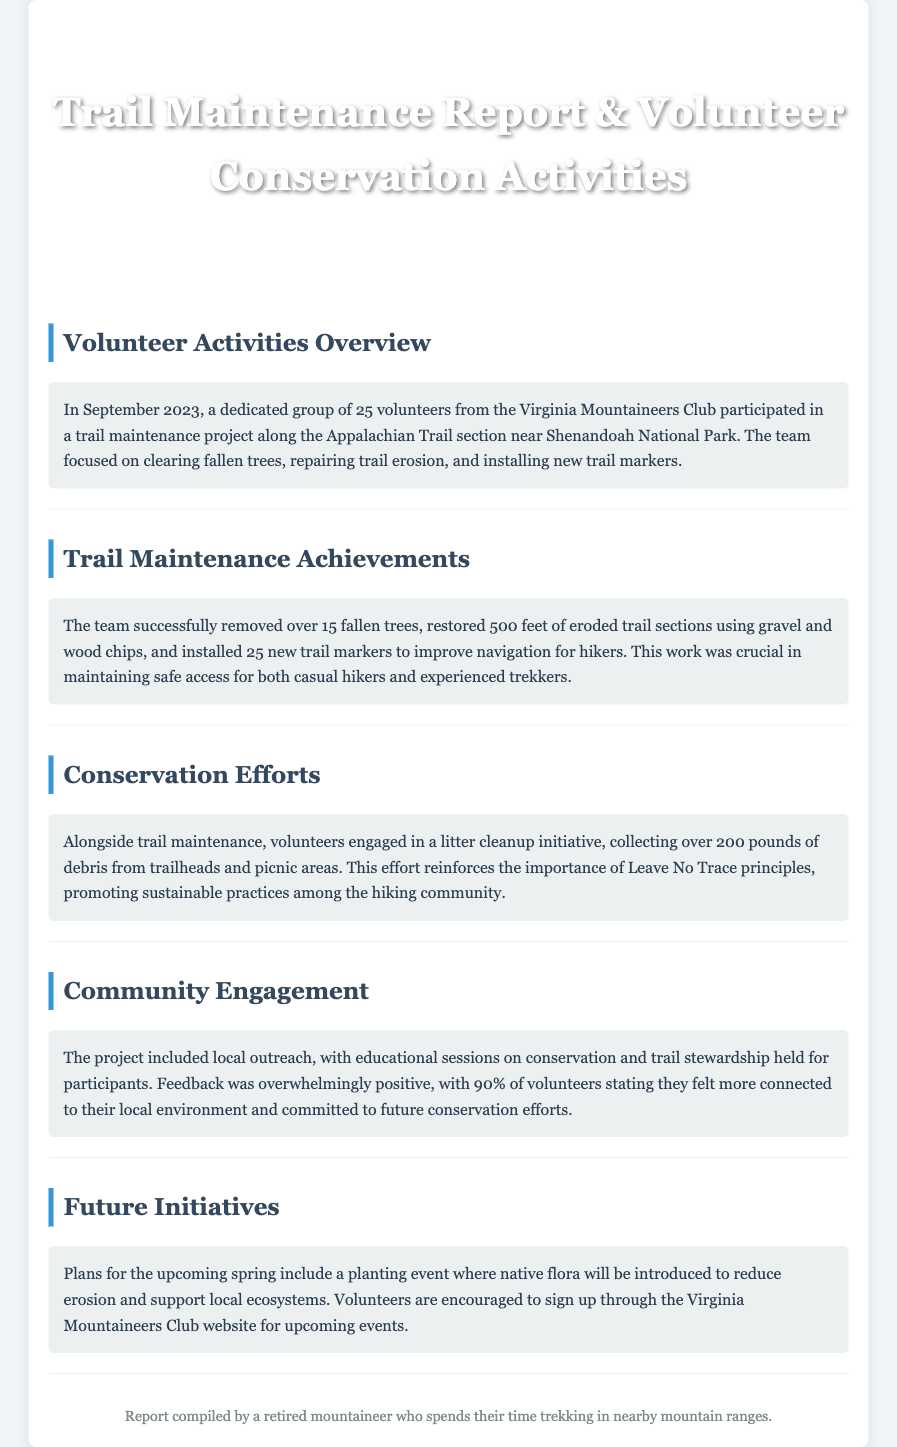What month did the volunteer activities take place? The document states that the volunteer activities occurred in September 2023.
Answer: September 2023 How many volunteers participated in the trail maintenance project? The document mentions that 25 volunteers from the Virginia Mountaineers Club took part in the project.
Answer: 25 volunteers What specific trail was the focus of the maintenance project? The maintenance project focused on a section of the Appalachian Trail near Shenandoah National Park.
Answer: Appalachian Trail How many fallen trees were removed by the volunteers? The document details that over 15 fallen trees were successfully removed during the project.
Answer: Over 15 What percentage of volunteers felt more connected to their local environment? The document indicates that 90% of volunteers reported feeling more connected to their local environment.
Answer: 90% What is one of the future initiatives planned for the upcoming spring? The document mentions a planting event where native flora will be introduced.
Answer: Planting event How many pounds of debris were collected during the litter cleanup? The document states that volunteers collected over 200 pounds of debris from trailheads and picnic areas.
Answer: Over 200 pounds What was one of the main focuses of the educational sessions held for participants? The document highlights that sessions were centered on conservation and trail stewardship.
Answer: Conservation and trail stewardship 